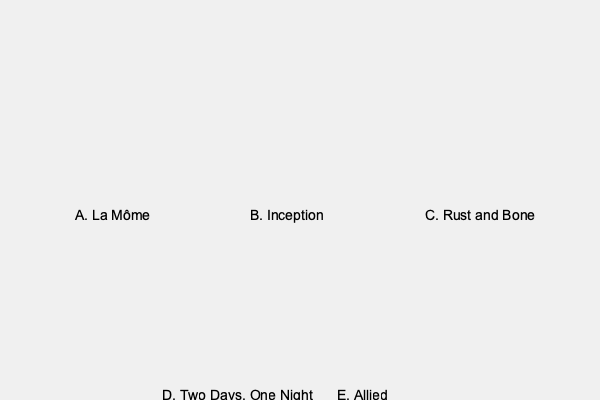Which image best represents Marion Cotillard's facial expression in her Oscar-winning role as Édith Piaf in "La Vie en Rose" (La Môme)? To answer this question, we need to analyze Marion Cotillard's facial expressions in each image and compare them to her portrayal of Édith Piaf in "La Vie en Rose" (La Môme):

1. Image A: This shows Marion with a serious, intense expression, with her head slightly tilted. This matches her portrayal of Édith Piaf, known for her passionate and dramatic performances.

2. Image B: Here, Marion has a more relaxed and subtle smile. This doesn't match the intensity of Édith Piaf's character.

3. Image C: This image shows Marion with a bright, open smile. While Édith Piaf had moments of joy, this expression is too carefree for her generally dramatic persona.

4. Image D: Marion appears contemplative and somewhat melancholic in this image. While it could fit some moments in Piaf's life, it's not the most representative of her stage presence.

5. Image E: This shows Marion with a glamorous, confident smile. While Piaf was a star, this expression is too modern and doesn't capture her signature intensity.

Among these options, Image A best represents Marion Cotillard's portrayal of Édith Piaf in "La Vie en Rose." The intense, serious expression captures the emotional depth and dramatic flair that Cotillard brought to the role, which ultimately earned her an Academy Award for Best Actress.
Answer: A 